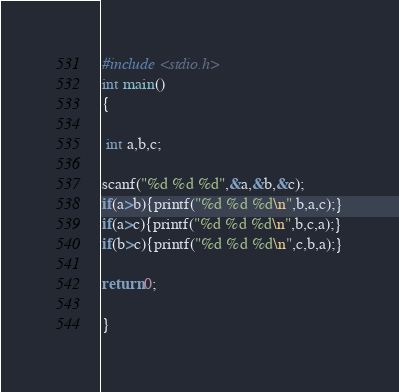<code> <loc_0><loc_0><loc_500><loc_500><_C_>#include <stdio.h>
int main()
{

 int a,b,c;

scanf("%d %d %d",&a,&b,&c);
if(a>b){printf("%d %d %d\n",b,a,c);}
if(a>c){printf("%d %d %d\n",b,c,a);}
if(b>c){printf("%d %d %d\n",c,b,a);}

return 0;

}</code> 